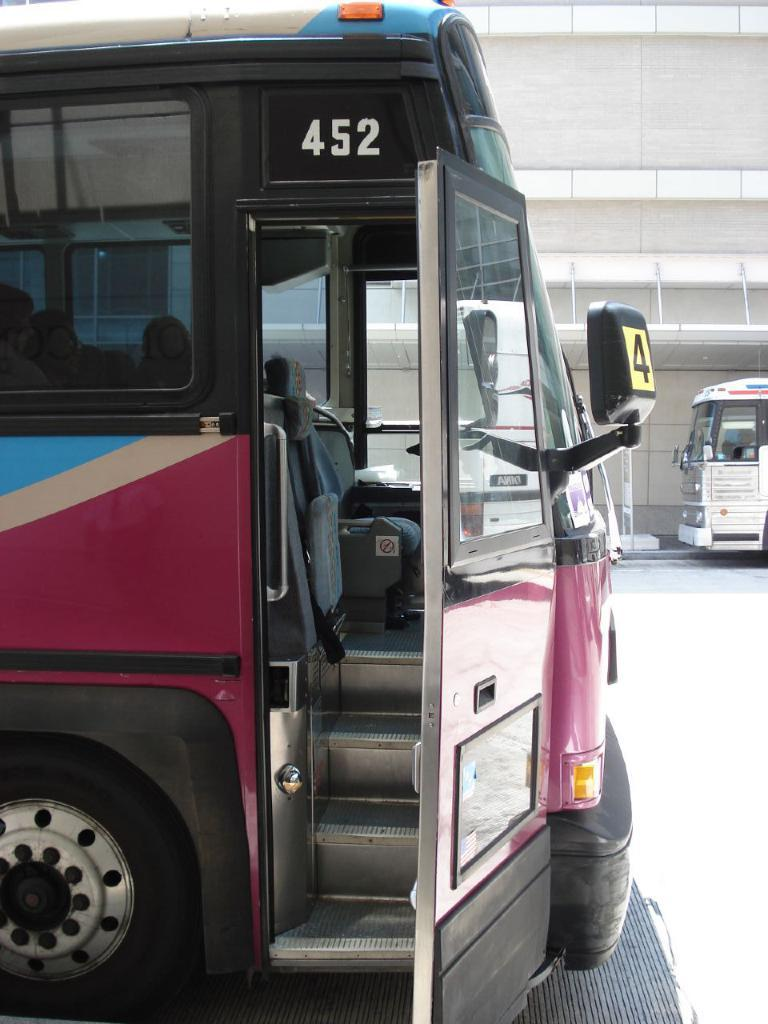<image>
Offer a succinct explanation of the picture presented. Bus number 452 is parked with its door open. 